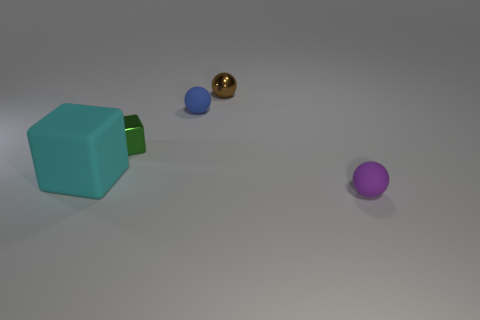Is there anything else that has the same size as the matte block?
Provide a short and direct response. No. What number of big cyan cubes are left of the cube behind the large cyan object in front of the small brown metal sphere?
Your answer should be compact. 1. There is a thing that is made of the same material as the green block; what is its size?
Your answer should be very brief. Small. Is the number of shiny balls that are in front of the tiny brown metal thing greater than the number of large gray cylinders?
Your answer should be very brief. No. The small green thing in front of the small metallic object that is behind the small rubber object that is behind the big matte object is made of what material?
Provide a short and direct response. Metal. Is the tiny brown object made of the same material as the tiny ball that is in front of the big rubber cube?
Offer a terse response. No. There is another object that is the same shape as the small green object; what is it made of?
Provide a short and direct response. Rubber. Is the number of small blue matte objects that are right of the tiny metal block greater than the number of blue rubber spheres that are behind the tiny blue rubber object?
Ensure brevity in your answer.  Yes. The tiny thing that is the same material as the tiny green cube is what shape?
Ensure brevity in your answer.  Sphere. What number of other things are there of the same shape as the purple thing?
Provide a succinct answer. 2. 